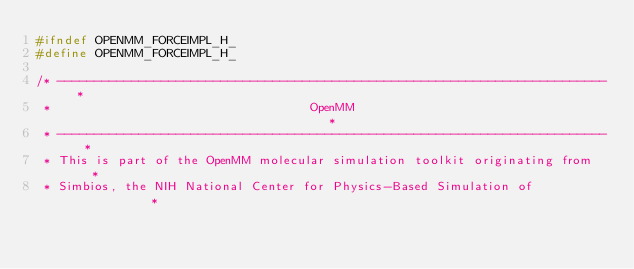Convert code to text. <code><loc_0><loc_0><loc_500><loc_500><_C_>#ifndef OPENMM_FORCEIMPL_H_
#define OPENMM_FORCEIMPL_H_

/* -------------------------------------------------------------------------- *
 *                                   OpenMM                                   *
 * -------------------------------------------------------------------------- *
 * This is part of the OpenMM molecular simulation toolkit originating from   *
 * Simbios, the NIH National Center for Physics-Based Simulation of           *</code> 